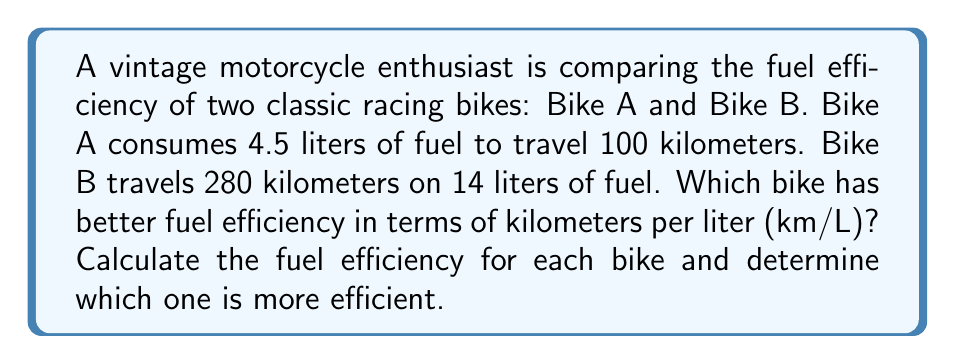Can you solve this math problem? To solve this problem, we need to calculate the fuel efficiency for each bike in kilometers per liter (km/L) and then compare them.

For Bike A:
We are given that it uses 4.5 liters for 100 km.
Fuel efficiency = Distance / Fuel consumed
$$ \text{Efficiency}_A = \frac{100 \text{ km}}{4.5 \text{ L}} = 22.22 \text{ km/L} $$

For Bike B:
We are given that it travels 280 km on 14 liters.
$$ \text{Efficiency}_B = \frac{280 \text{ km}}{14 \text{ L}} = 20 \text{ km/L} $$

Now we can compare the two efficiencies:
$$ 22.22 \text{ km/L} > 20 \text{ km/L} $$

Therefore, Bike A has better fuel efficiency than Bike B.
Answer: Bike A has better fuel efficiency with 22.22 km/L compared to Bike B's 20 km/L. 